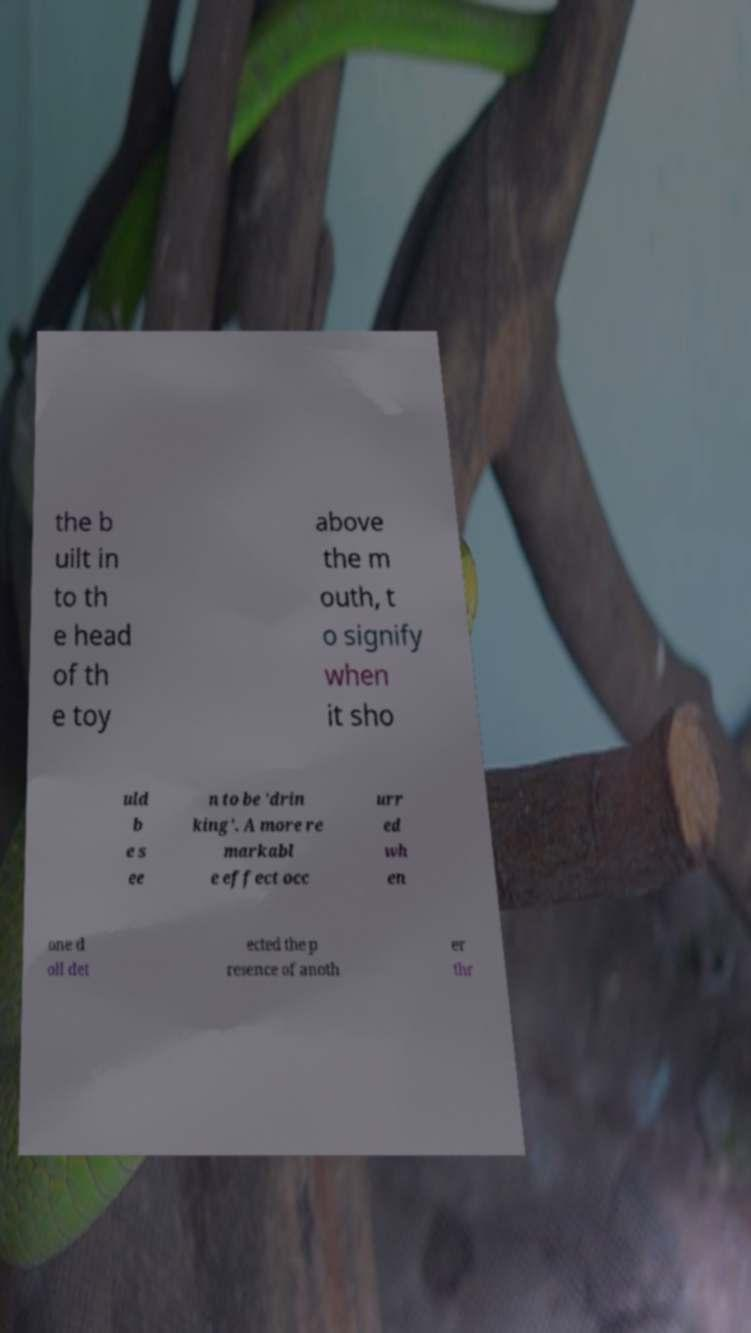Can you read and provide the text displayed in the image?This photo seems to have some interesting text. Can you extract and type it out for me? the b uilt in to th e head of th e toy above the m outh, t o signify when it sho uld b e s ee n to be 'drin king'. A more re markabl e effect occ urr ed wh en one d oll det ected the p resence of anoth er thr 